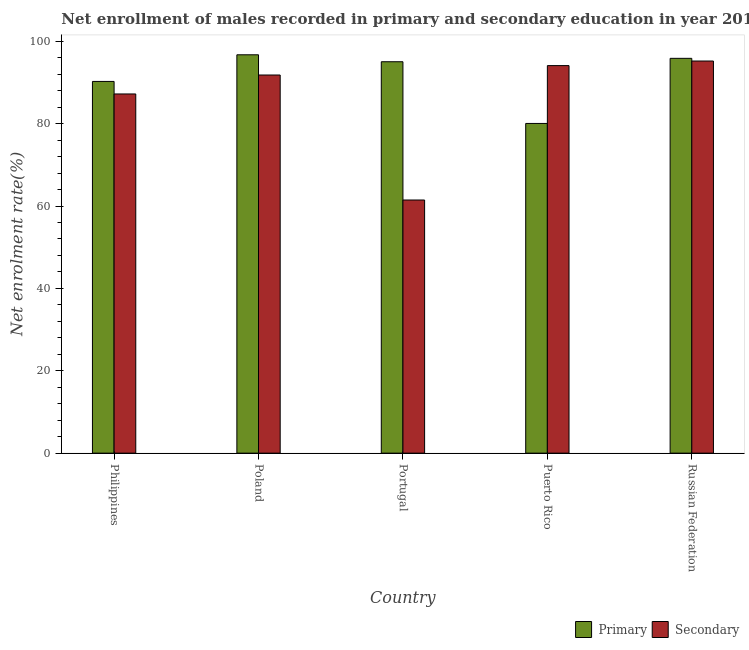How many different coloured bars are there?
Your answer should be very brief. 2. Are the number of bars on each tick of the X-axis equal?
Your response must be concise. Yes. What is the label of the 4th group of bars from the left?
Your answer should be compact. Puerto Rico. What is the enrollment rate in secondary education in Puerto Rico?
Offer a very short reply. 94.1. Across all countries, what is the maximum enrollment rate in primary education?
Your answer should be very brief. 96.72. Across all countries, what is the minimum enrollment rate in primary education?
Provide a succinct answer. 80.05. In which country was the enrollment rate in primary education maximum?
Provide a succinct answer. Poland. In which country was the enrollment rate in primary education minimum?
Keep it short and to the point. Puerto Rico. What is the total enrollment rate in primary education in the graph?
Provide a short and direct response. 457.92. What is the difference between the enrollment rate in primary education in Puerto Rico and that in Russian Federation?
Offer a terse response. -15.81. What is the difference between the enrollment rate in secondary education in Puerto Rico and the enrollment rate in primary education in Philippines?
Give a very brief answer. 3.84. What is the average enrollment rate in secondary education per country?
Ensure brevity in your answer.  85.96. What is the difference between the enrollment rate in primary education and enrollment rate in secondary education in Russian Federation?
Provide a short and direct response. 0.65. In how many countries, is the enrollment rate in secondary education greater than 32 %?
Offer a terse response. 5. What is the ratio of the enrollment rate in secondary education in Philippines to that in Portugal?
Your answer should be very brief. 1.42. Is the difference between the enrollment rate in primary education in Puerto Rico and Russian Federation greater than the difference between the enrollment rate in secondary education in Puerto Rico and Russian Federation?
Ensure brevity in your answer.  No. What is the difference between the highest and the second highest enrollment rate in secondary education?
Keep it short and to the point. 1.11. What is the difference between the highest and the lowest enrollment rate in secondary education?
Give a very brief answer. 33.75. Is the sum of the enrollment rate in primary education in Poland and Puerto Rico greater than the maximum enrollment rate in secondary education across all countries?
Make the answer very short. Yes. What does the 1st bar from the left in Portugal represents?
Provide a short and direct response. Primary. What does the 1st bar from the right in Puerto Rico represents?
Ensure brevity in your answer.  Secondary. How many countries are there in the graph?
Your answer should be compact. 5. What is the difference between two consecutive major ticks on the Y-axis?
Provide a short and direct response. 20. Does the graph contain any zero values?
Keep it short and to the point. No. Does the graph contain grids?
Your response must be concise. No. What is the title of the graph?
Provide a succinct answer. Net enrollment of males recorded in primary and secondary education in year 2013. What is the label or title of the X-axis?
Make the answer very short. Country. What is the label or title of the Y-axis?
Offer a very short reply. Net enrolment rate(%). What is the Net enrolment rate(%) of Primary in Philippines?
Make the answer very short. 90.25. What is the Net enrolment rate(%) in Secondary in Philippines?
Provide a succinct answer. 87.21. What is the Net enrolment rate(%) of Primary in Poland?
Offer a very short reply. 96.72. What is the Net enrolment rate(%) of Secondary in Poland?
Give a very brief answer. 91.82. What is the Net enrolment rate(%) of Primary in Portugal?
Give a very brief answer. 95.03. What is the Net enrolment rate(%) in Secondary in Portugal?
Offer a terse response. 61.46. What is the Net enrolment rate(%) in Primary in Puerto Rico?
Your response must be concise. 80.05. What is the Net enrolment rate(%) of Secondary in Puerto Rico?
Provide a short and direct response. 94.1. What is the Net enrolment rate(%) in Primary in Russian Federation?
Your answer should be compact. 95.86. What is the Net enrolment rate(%) of Secondary in Russian Federation?
Your response must be concise. 95.21. Across all countries, what is the maximum Net enrolment rate(%) in Primary?
Keep it short and to the point. 96.72. Across all countries, what is the maximum Net enrolment rate(%) of Secondary?
Offer a terse response. 95.21. Across all countries, what is the minimum Net enrolment rate(%) of Primary?
Provide a succinct answer. 80.05. Across all countries, what is the minimum Net enrolment rate(%) in Secondary?
Your answer should be compact. 61.46. What is the total Net enrolment rate(%) in Primary in the graph?
Offer a terse response. 457.92. What is the total Net enrolment rate(%) of Secondary in the graph?
Offer a very short reply. 429.8. What is the difference between the Net enrolment rate(%) in Primary in Philippines and that in Poland?
Offer a very short reply. -6.47. What is the difference between the Net enrolment rate(%) of Secondary in Philippines and that in Poland?
Provide a succinct answer. -4.6. What is the difference between the Net enrolment rate(%) of Primary in Philippines and that in Portugal?
Ensure brevity in your answer.  -4.78. What is the difference between the Net enrolment rate(%) of Secondary in Philippines and that in Portugal?
Ensure brevity in your answer.  25.75. What is the difference between the Net enrolment rate(%) of Primary in Philippines and that in Puerto Rico?
Provide a succinct answer. 10.2. What is the difference between the Net enrolment rate(%) of Secondary in Philippines and that in Puerto Rico?
Make the answer very short. -6.88. What is the difference between the Net enrolment rate(%) in Primary in Philippines and that in Russian Federation?
Ensure brevity in your answer.  -5.61. What is the difference between the Net enrolment rate(%) in Secondary in Philippines and that in Russian Federation?
Your answer should be very brief. -8. What is the difference between the Net enrolment rate(%) in Primary in Poland and that in Portugal?
Give a very brief answer. 1.69. What is the difference between the Net enrolment rate(%) in Secondary in Poland and that in Portugal?
Provide a succinct answer. 30.35. What is the difference between the Net enrolment rate(%) in Primary in Poland and that in Puerto Rico?
Provide a succinct answer. 16.67. What is the difference between the Net enrolment rate(%) in Secondary in Poland and that in Puerto Rico?
Offer a very short reply. -2.28. What is the difference between the Net enrolment rate(%) of Primary in Poland and that in Russian Federation?
Ensure brevity in your answer.  0.86. What is the difference between the Net enrolment rate(%) in Secondary in Poland and that in Russian Federation?
Give a very brief answer. -3.39. What is the difference between the Net enrolment rate(%) of Primary in Portugal and that in Puerto Rico?
Provide a short and direct response. 14.98. What is the difference between the Net enrolment rate(%) in Secondary in Portugal and that in Puerto Rico?
Make the answer very short. -32.64. What is the difference between the Net enrolment rate(%) of Primary in Portugal and that in Russian Federation?
Offer a very short reply. -0.83. What is the difference between the Net enrolment rate(%) of Secondary in Portugal and that in Russian Federation?
Offer a very short reply. -33.75. What is the difference between the Net enrolment rate(%) in Primary in Puerto Rico and that in Russian Federation?
Give a very brief answer. -15.81. What is the difference between the Net enrolment rate(%) of Secondary in Puerto Rico and that in Russian Federation?
Make the answer very short. -1.11. What is the difference between the Net enrolment rate(%) of Primary in Philippines and the Net enrolment rate(%) of Secondary in Poland?
Ensure brevity in your answer.  -1.56. What is the difference between the Net enrolment rate(%) of Primary in Philippines and the Net enrolment rate(%) of Secondary in Portugal?
Ensure brevity in your answer.  28.79. What is the difference between the Net enrolment rate(%) in Primary in Philippines and the Net enrolment rate(%) in Secondary in Puerto Rico?
Make the answer very short. -3.84. What is the difference between the Net enrolment rate(%) of Primary in Philippines and the Net enrolment rate(%) of Secondary in Russian Federation?
Your response must be concise. -4.96. What is the difference between the Net enrolment rate(%) in Primary in Poland and the Net enrolment rate(%) in Secondary in Portugal?
Your answer should be compact. 35.26. What is the difference between the Net enrolment rate(%) of Primary in Poland and the Net enrolment rate(%) of Secondary in Puerto Rico?
Keep it short and to the point. 2.63. What is the difference between the Net enrolment rate(%) of Primary in Poland and the Net enrolment rate(%) of Secondary in Russian Federation?
Keep it short and to the point. 1.51. What is the difference between the Net enrolment rate(%) in Primary in Portugal and the Net enrolment rate(%) in Secondary in Puerto Rico?
Give a very brief answer. 0.94. What is the difference between the Net enrolment rate(%) in Primary in Portugal and the Net enrolment rate(%) in Secondary in Russian Federation?
Give a very brief answer. -0.18. What is the difference between the Net enrolment rate(%) of Primary in Puerto Rico and the Net enrolment rate(%) of Secondary in Russian Federation?
Make the answer very short. -15.16. What is the average Net enrolment rate(%) in Primary per country?
Offer a very short reply. 91.58. What is the average Net enrolment rate(%) of Secondary per country?
Your answer should be compact. 85.96. What is the difference between the Net enrolment rate(%) of Primary and Net enrolment rate(%) of Secondary in Philippines?
Provide a short and direct response. 3.04. What is the difference between the Net enrolment rate(%) in Primary and Net enrolment rate(%) in Secondary in Poland?
Make the answer very short. 4.91. What is the difference between the Net enrolment rate(%) in Primary and Net enrolment rate(%) in Secondary in Portugal?
Your answer should be very brief. 33.57. What is the difference between the Net enrolment rate(%) in Primary and Net enrolment rate(%) in Secondary in Puerto Rico?
Give a very brief answer. -14.04. What is the difference between the Net enrolment rate(%) in Primary and Net enrolment rate(%) in Secondary in Russian Federation?
Your response must be concise. 0.65. What is the ratio of the Net enrolment rate(%) in Primary in Philippines to that in Poland?
Give a very brief answer. 0.93. What is the ratio of the Net enrolment rate(%) of Secondary in Philippines to that in Poland?
Give a very brief answer. 0.95. What is the ratio of the Net enrolment rate(%) in Primary in Philippines to that in Portugal?
Your answer should be very brief. 0.95. What is the ratio of the Net enrolment rate(%) of Secondary in Philippines to that in Portugal?
Your answer should be compact. 1.42. What is the ratio of the Net enrolment rate(%) of Primary in Philippines to that in Puerto Rico?
Provide a short and direct response. 1.13. What is the ratio of the Net enrolment rate(%) of Secondary in Philippines to that in Puerto Rico?
Your answer should be compact. 0.93. What is the ratio of the Net enrolment rate(%) of Primary in Philippines to that in Russian Federation?
Offer a terse response. 0.94. What is the ratio of the Net enrolment rate(%) in Secondary in Philippines to that in Russian Federation?
Provide a succinct answer. 0.92. What is the ratio of the Net enrolment rate(%) of Primary in Poland to that in Portugal?
Keep it short and to the point. 1.02. What is the ratio of the Net enrolment rate(%) of Secondary in Poland to that in Portugal?
Your answer should be compact. 1.49. What is the ratio of the Net enrolment rate(%) of Primary in Poland to that in Puerto Rico?
Your answer should be compact. 1.21. What is the ratio of the Net enrolment rate(%) of Secondary in Poland to that in Puerto Rico?
Provide a succinct answer. 0.98. What is the ratio of the Net enrolment rate(%) in Secondary in Poland to that in Russian Federation?
Your answer should be compact. 0.96. What is the ratio of the Net enrolment rate(%) of Primary in Portugal to that in Puerto Rico?
Keep it short and to the point. 1.19. What is the ratio of the Net enrolment rate(%) in Secondary in Portugal to that in Puerto Rico?
Offer a terse response. 0.65. What is the ratio of the Net enrolment rate(%) of Primary in Portugal to that in Russian Federation?
Offer a terse response. 0.99. What is the ratio of the Net enrolment rate(%) in Secondary in Portugal to that in Russian Federation?
Your answer should be compact. 0.65. What is the ratio of the Net enrolment rate(%) in Primary in Puerto Rico to that in Russian Federation?
Provide a succinct answer. 0.84. What is the ratio of the Net enrolment rate(%) in Secondary in Puerto Rico to that in Russian Federation?
Keep it short and to the point. 0.99. What is the difference between the highest and the second highest Net enrolment rate(%) in Primary?
Make the answer very short. 0.86. What is the difference between the highest and the second highest Net enrolment rate(%) in Secondary?
Your answer should be very brief. 1.11. What is the difference between the highest and the lowest Net enrolment rate(%) of Primary?
Keep it short and to the point. 16.67. What is the difference between the highest and the lowest Net enrolment rate(%) of Secondary?
Ensure brevity in your answer.  33.75. 